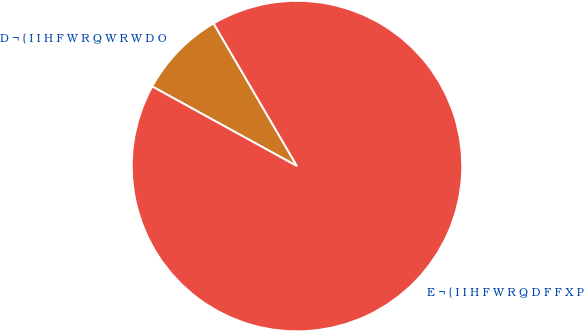Convert chart. <chart><loc_0><loc_0><loc_500><loc_500><pie_chart><fcel>D ¬ ( I I H F W R Q W R W D O<fcel>E ¬ ( I I H F W R Q D F F X P<nl><fcel>8.58%<fcel>91.42%<nl></chart> 